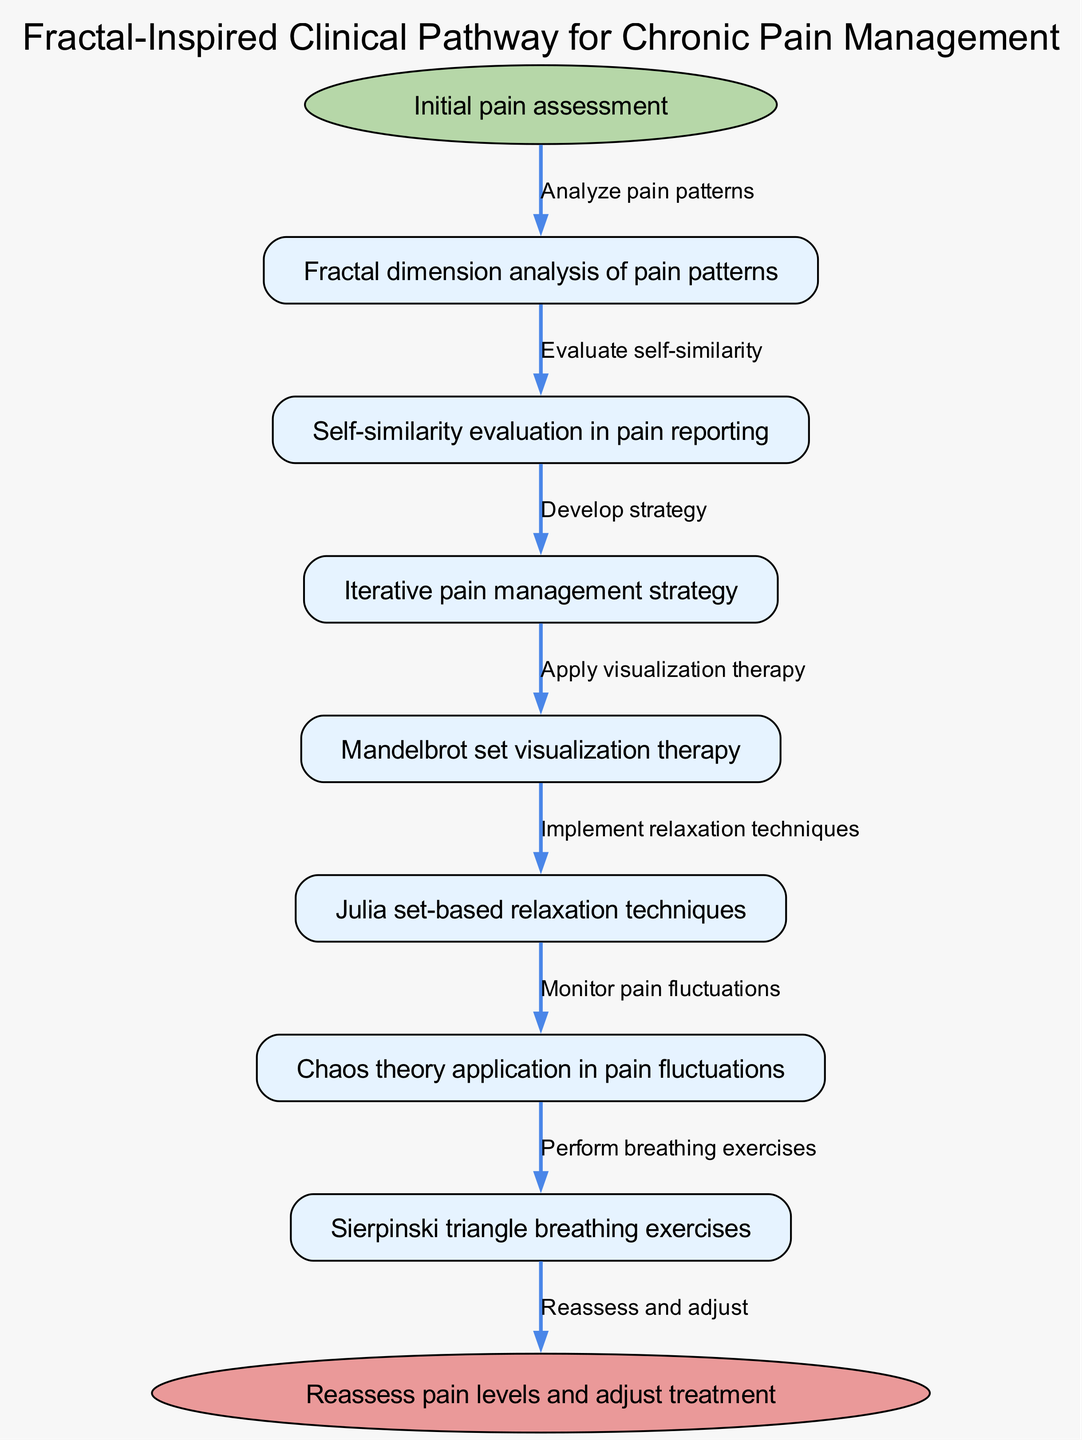What is the starting point of the clinical pathway? The starting point is explicitly mentioned at the top of the diagram as "Initial pain assessment".
Answer: Initial pain assessment How many nodes are present in the diagram? The diagram lists a total of 7 nodes, which include various treatments and evaluations related to chronic pain management.
Answer: 7 What is the last node before the endpoint? The last node listed in the diagram is "Chaos theory application in pain fluctuations", which directly connects to the endpoint.
Answer: Chaos theory application in pain fluctuations What edge connects the start point to the first node? The edge connecting the start point to the first node is labeled "Analyze pain patterns", as shown in the diagram flow.
Answer: Analyze pain patterns Which technique is related to relaxation? "Julia set-based relaxation techniques" is specifically identified within the nodes as a relaxation strategy.
Answer: Julia set-based relaxation techniques What is the purpose of the final endpoint in the pathway? The endpoint indicates the action to "Reassess pain levels and adjust treatment," summarizing the process outcome.
Answer: Reassess pain levels and adjust treatment Which node involves fractal dimension analysis? The node labeled "Fractal dimension analysis of pain patterns" directly refers to this concept within the treatment strategy.
Answer: Fractal dimension analysis of pain patterns How do the nodes relate to the iterative pain management strategy? The "Iterative pain management strategy" node serves as a key central point in the pathway that connects with various techniques and evaluations.
Answer: Iterative pain management strategy What breathing exercise technique is included in the diagram? The node labeled "Sierpinski triangle breathing exercises" refers to a specific technique within the pain management pathway.
Answer: Sierpinski triangle breathing exercises 